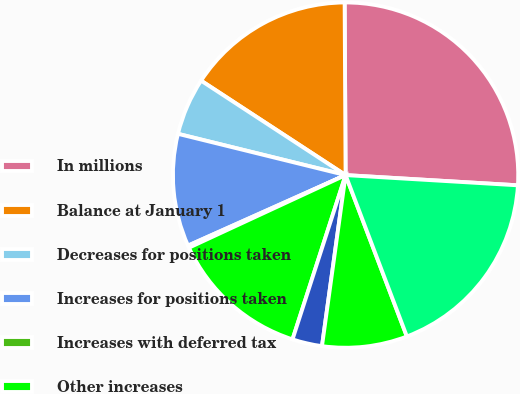<chart> <loc_0><loc_0><loc_500><loc_500><pie_chart><fcel>In millions<fcel>Balance at January 1<fcel>Decreases for positions taken<fcel>Increases for positions taken<fcel>Increases with deferred tax<fcel>Other increases<fcel>Settlements with taxing<fcel>Lapsing of statutes of<fcel>Balance at December 31 (1)(2)<nl><fcel>26.03%<fcel>15.7%<fcel>5.37%<fcel>10.54%<fcel>0.21%<fcel>13.12%<fcel>2.79%<fcel>7.96%<fcel>18.28%<nl></chart> 